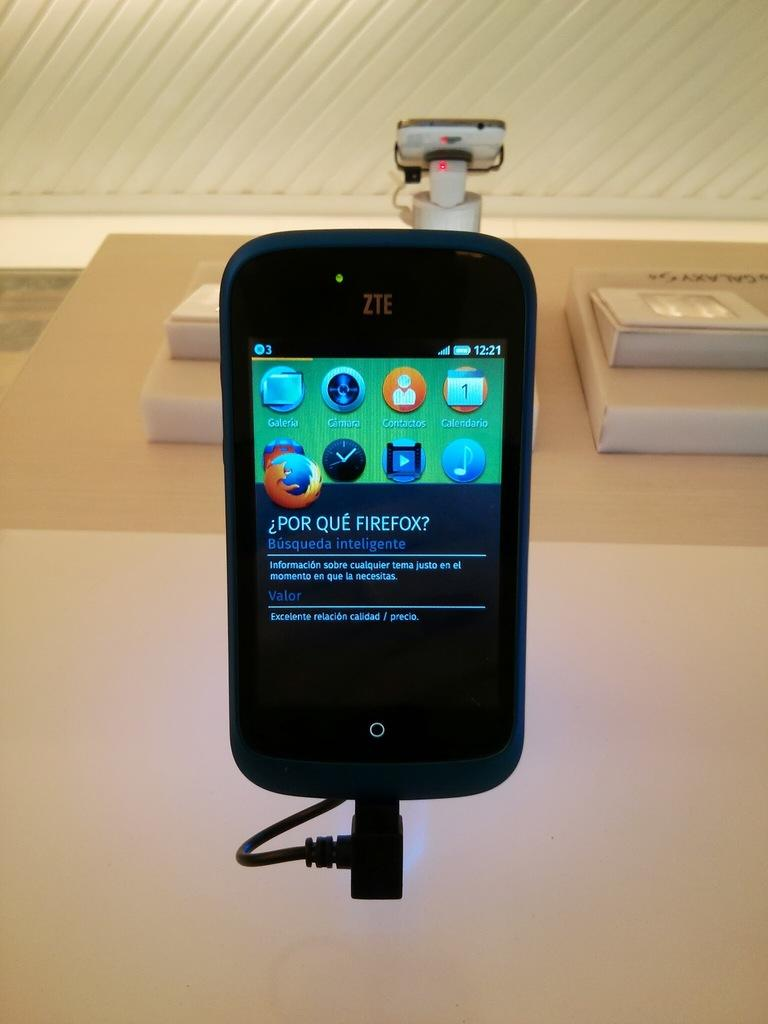<image>
Render a clear and concise summary of the photo. A ZTE phone open to a page with a firefox logo. 